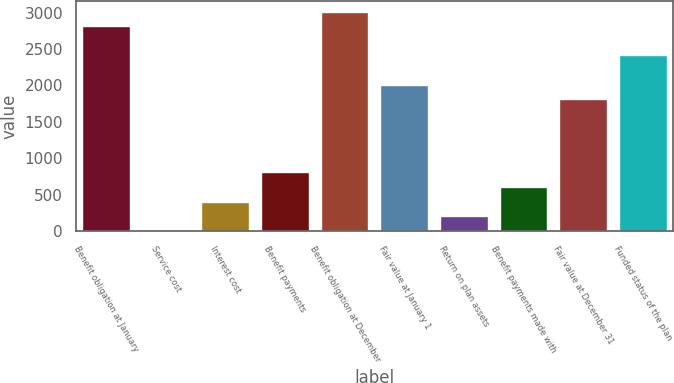<chart> <loc_0><loc_0><loc_500><loc_500><bar_chart><fcel>Benefit obligation at January<fcel>Service cost<fcel>Interest cost<fcel>Benefit payments<fcel>Benefit obligation at December<fcel>Fair value at January 1<fcel>Return on plan assets<fcel>Benefit payments made with<fcel>Fair value at December 31<fcel>Funded status of the plan<nl><fcel>2813.8<fcel>4<fcel>405.4<fcel>806.8<fcel>3014.5<fcel>2011<fcel>204.7<fcel>606.1<fcel>1810.3<fcel>2412.4<nl></chart> 